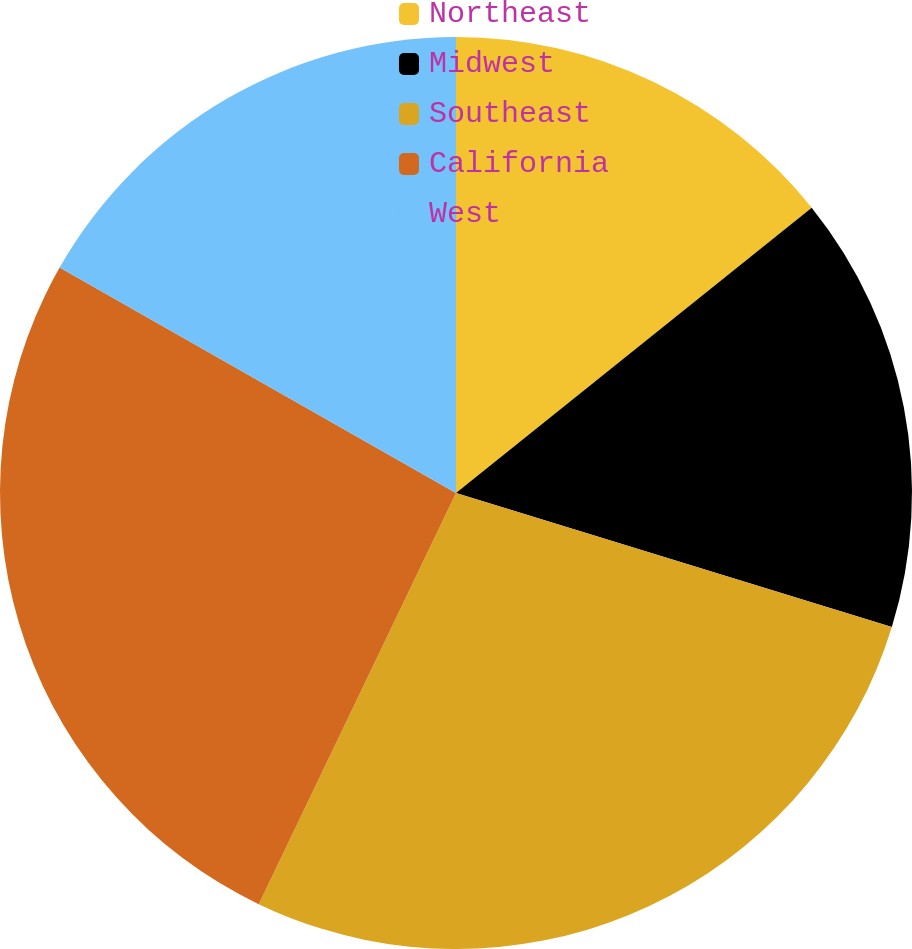<chart> <loc_0><loc_0><loc_500><loc_500><pie_chart><fcel>Northeast<fcel>Midwest<fcel>Southeast<fcel>California<fcel>West<nl><fcel>14.24%<fcel>15.51%<fcel>27.37%<fcel>26.11%<fcel>16.77%<nl></chart> 